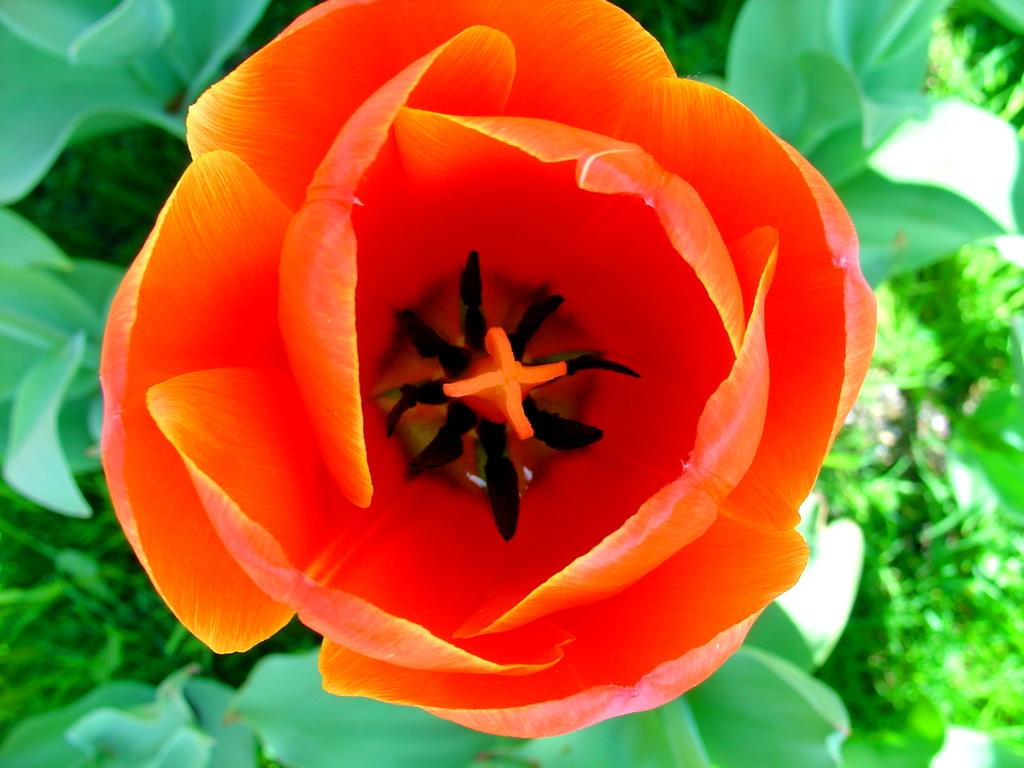What is the main subject of the image? There is a flower in the image. Can you describe the color of the flower? The flower has a reddish color. What else can be seen in the background of the image? There are leaves visible in the background of the image. How many girls are holding the flower in the image? There are no girls present in the image; it only features a flower and leaves. Can you tell me how many lizards are crawling on the flower in the image? There are no lizards present in the image; it only features a flower and leaves. 